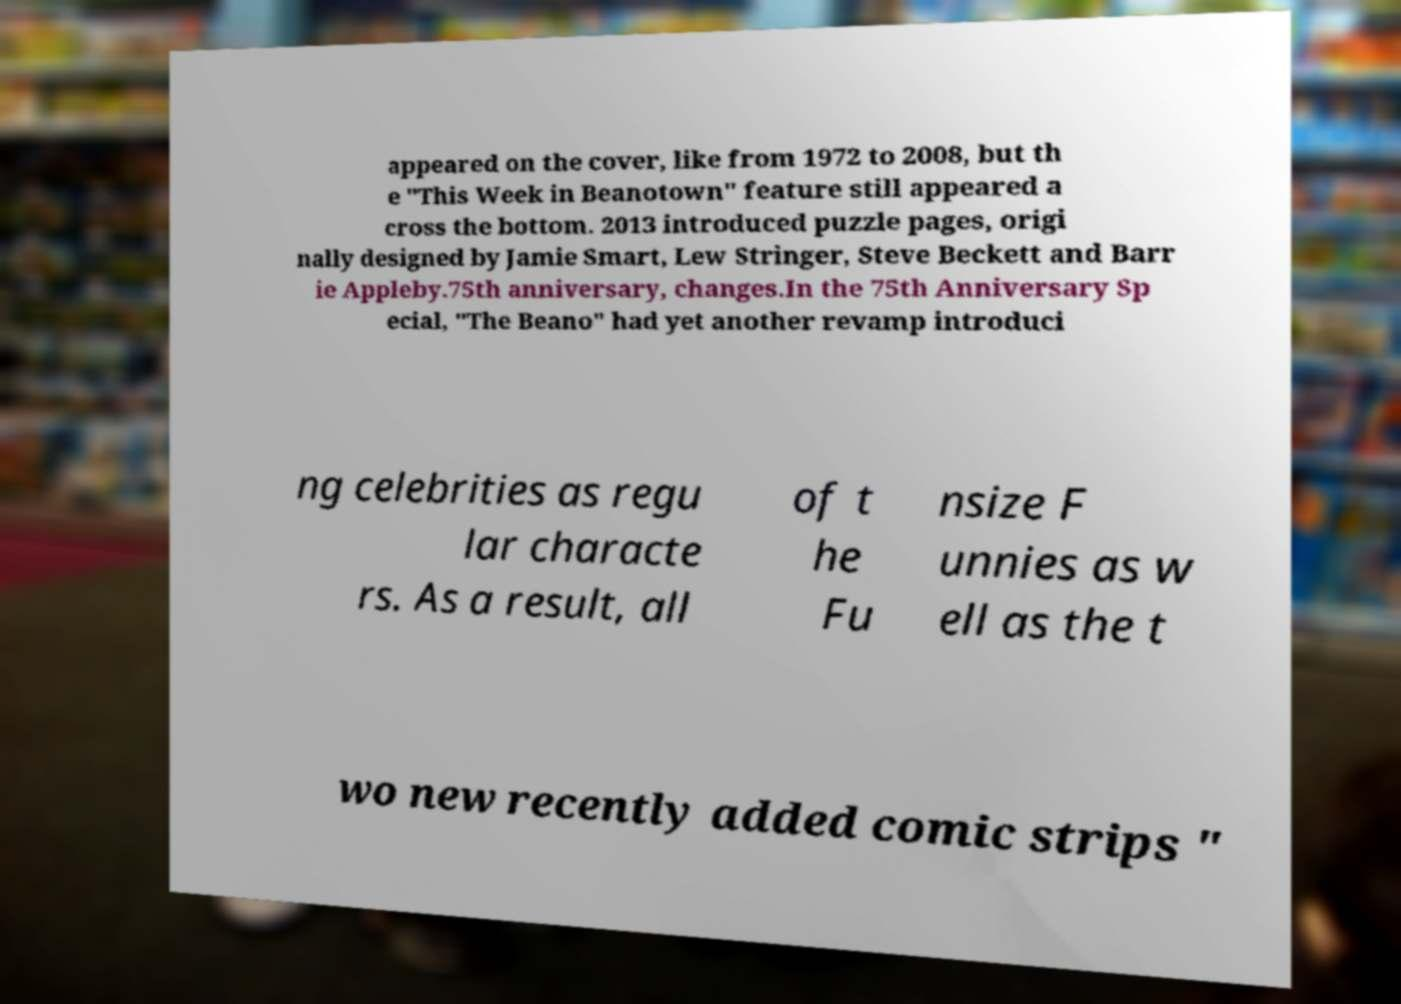There's text embedded in this image that I need extracted. Can you transcribe it verbatim? appeared on the cover, like from 1972 to 2008, but th e "This Week in Beanotown" feature still appeared a cross the bottom. 2013 introduced puzzle pages, origi nally designed by Jamie Smart, Lew Stringer, Steve Beckett and Barr ie Appleby.75th anniversary, changes.In the 75th Anniversary Sp ecial, "The Beano" had yet another revamp introduci ng celebrities as regu lar characte rs. As a result, all of t he Fu nsize F unnies as w ell as the t wo new recently added comic strips " 